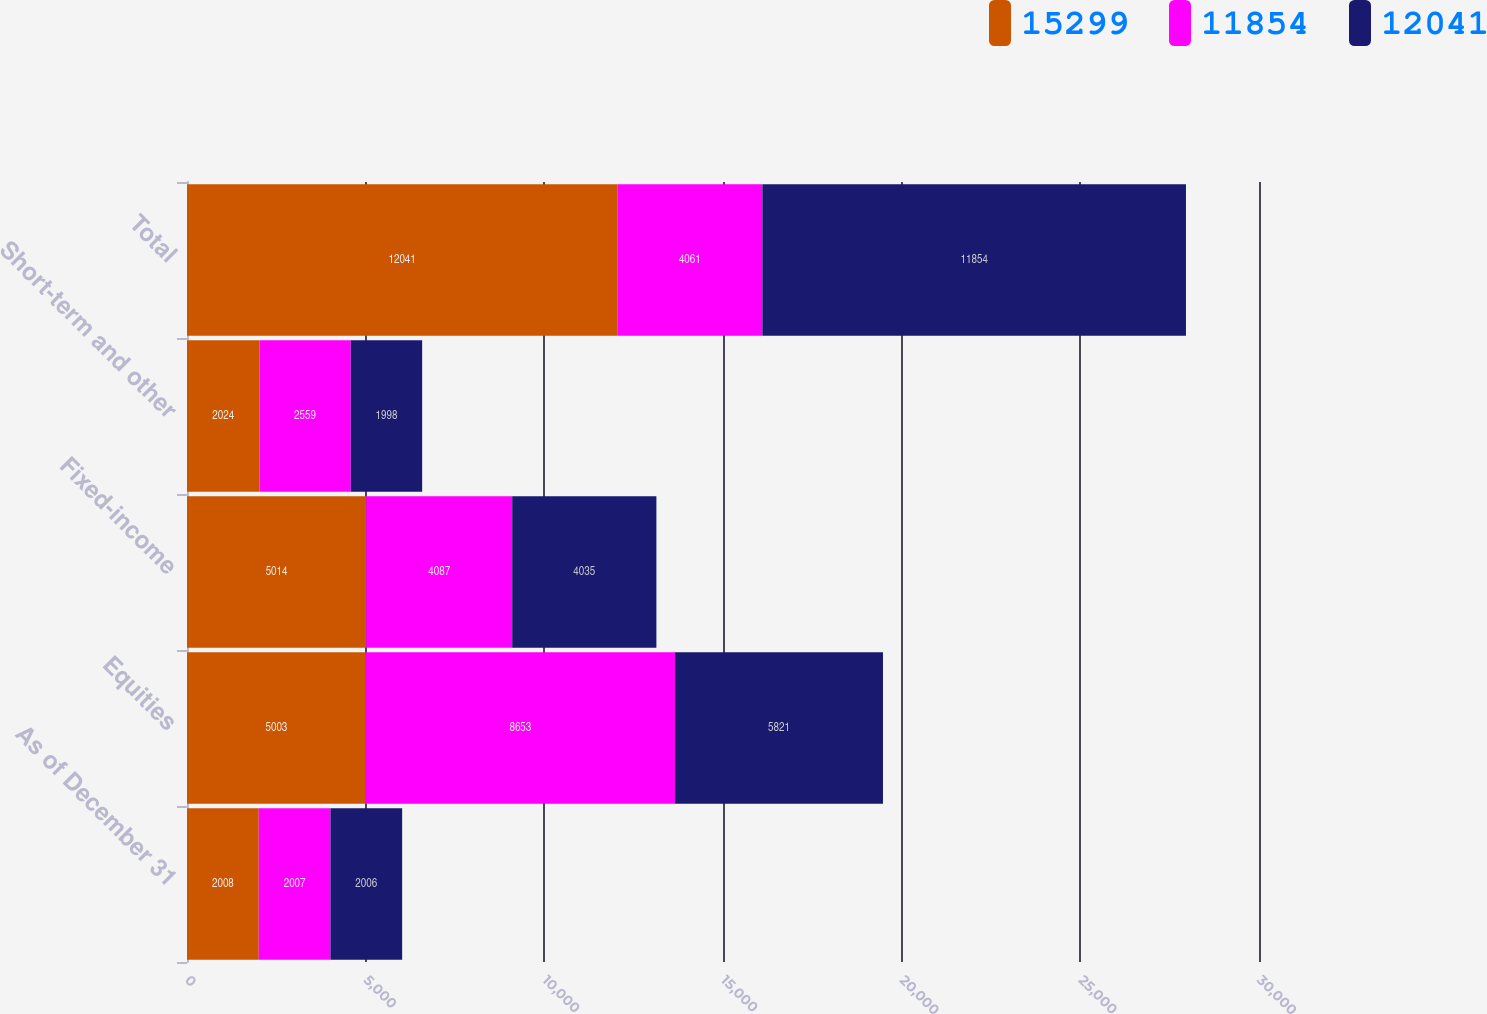Convert chart. <chart><loc_0><loc_0><loc_500><loc_500><stacked_bar_chart><ecel><fcel>As of December 31<fcel>Equities<fcel>Fixed-income<fcel>Short-term and other<fcel>Total<nl><fcel>15299<fcel>2008<fcel>5003<fcel>5014<fcel>2024<fcel>12041<nl><fcel>11854<fcel>2007<fcel>8653<fcel>4087<fcel>2559<fcel>4061<nl><fcel>12041<fcel>2006<fcel>5821<fcel>4035<fcel>1998<fcel>11854<nl></chart> 